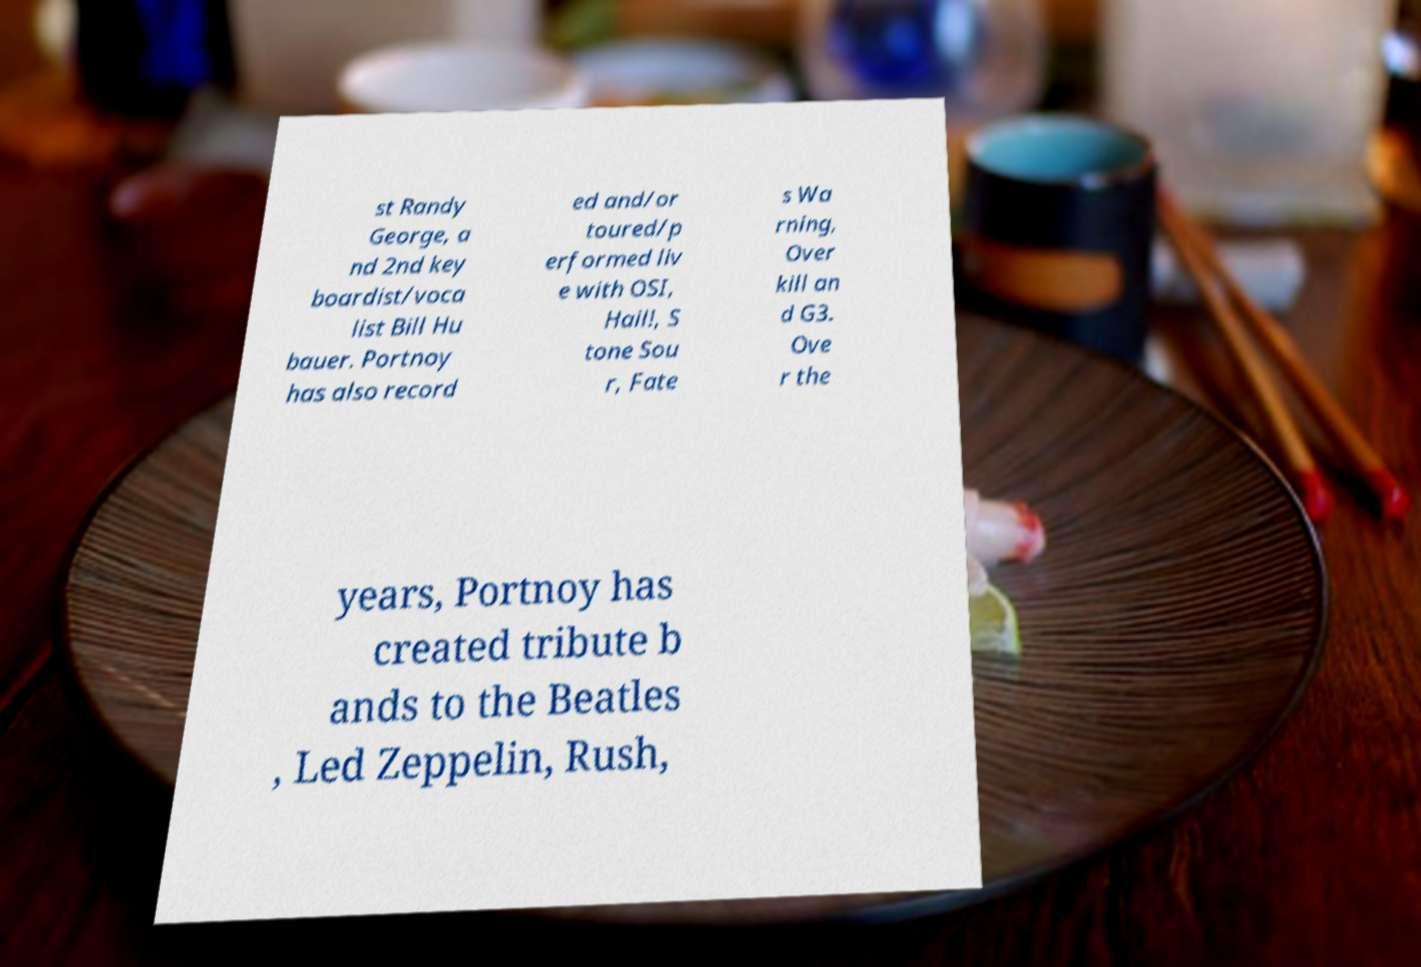Could you assist in decoding the text presented in this image and type it out clearly? st Randy George, a nd 2nd key boardist/voca list Bill Hu bauer. Portnoy has also record ed and/or toured/p erformed liv e with OSI, Hail!, S tone Sou r, Fate s Wa rning, Over kill an d G3. Ove r the years, Portnoy has created tribute b ands to the Beatles , Led Zeppelin, Rush, 